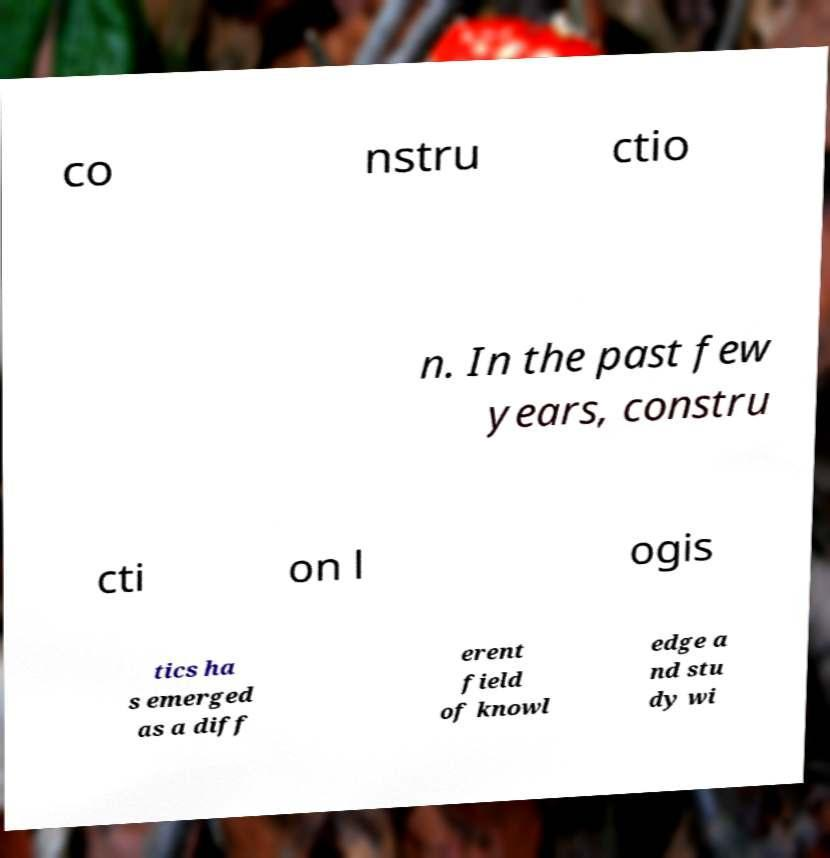Could you extract and type out the text from this image? co nstru ctio n. In the past few years, constru cti on l ogis tics ha s emerged as a diff erent field of knowl edge a nd stu dy wi 